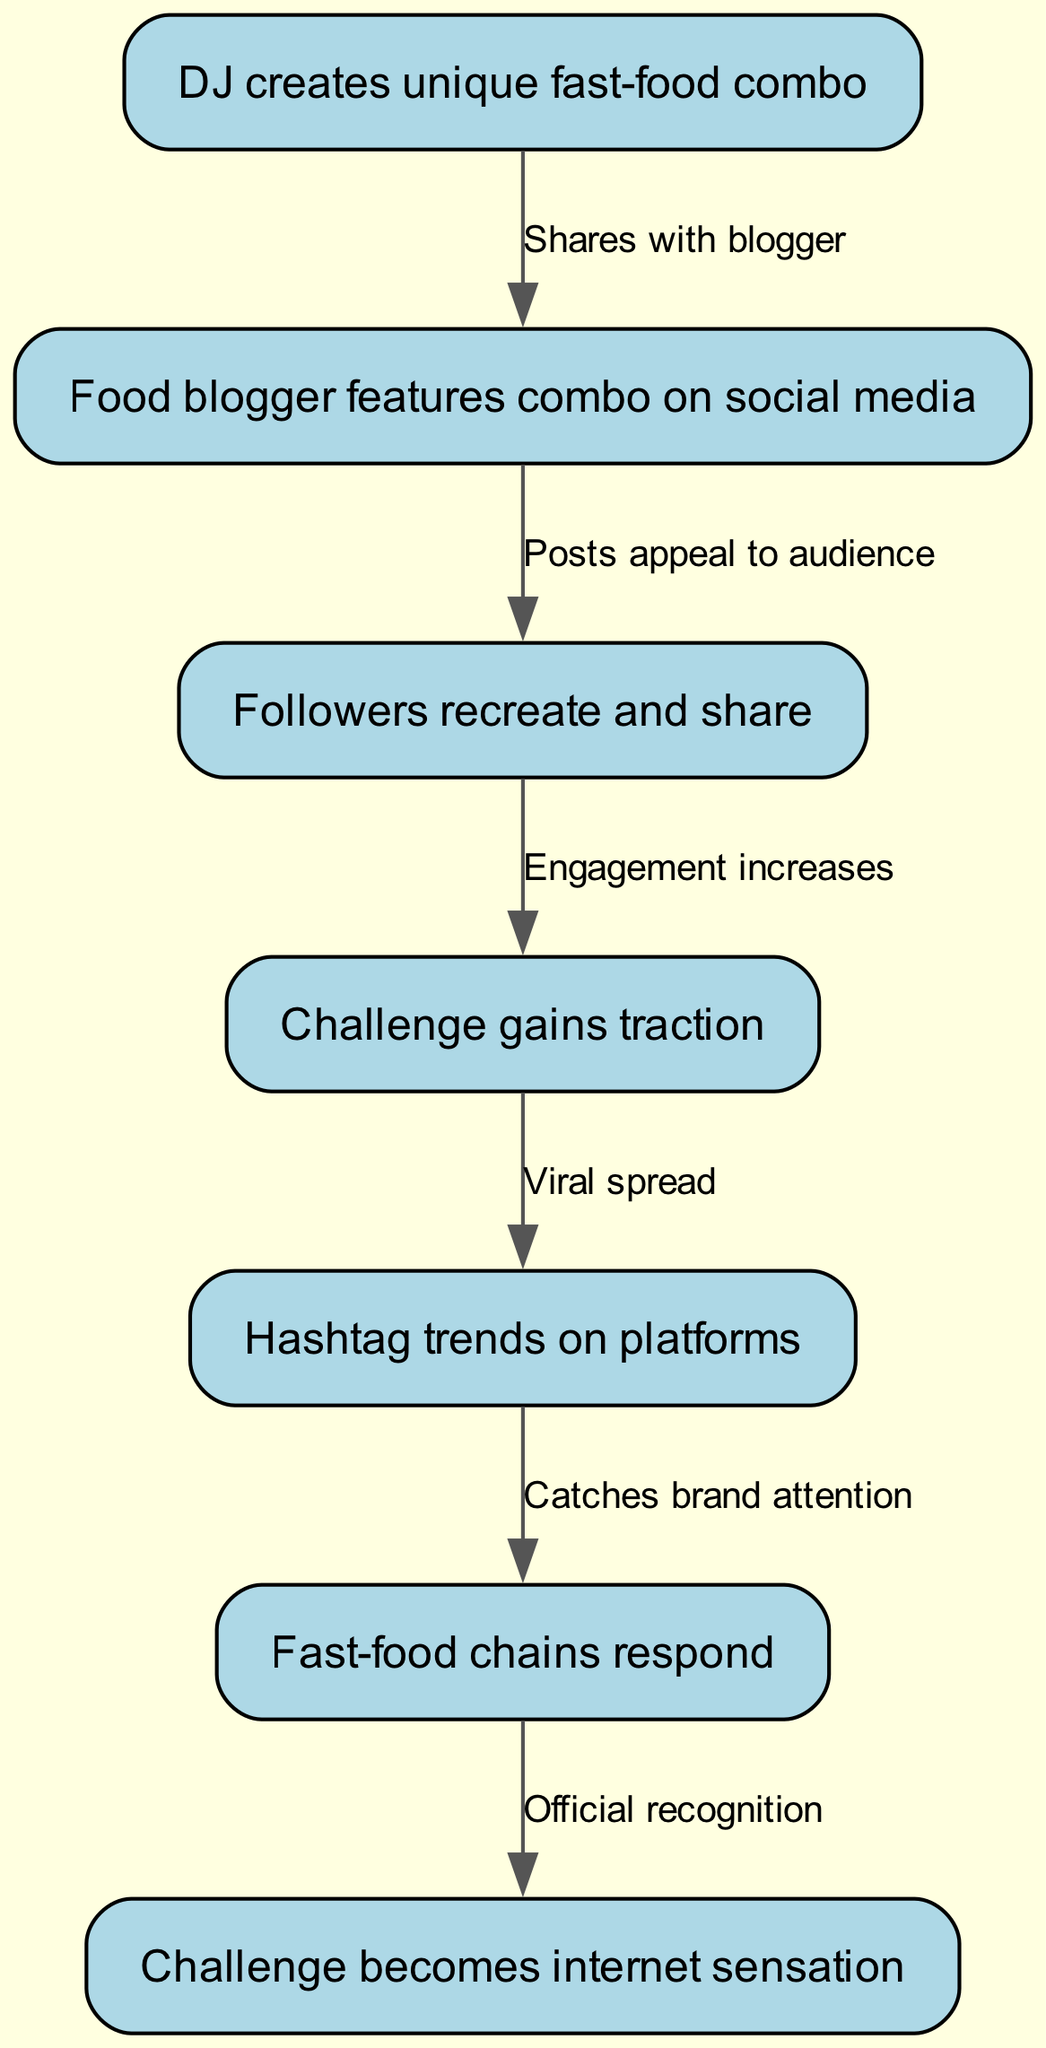What is the first step in the food challenge lifecycle? The first node in the diagram shows "DJ creates unique fast-food combo," indicating that this is where the lifecycle begins.
Answer: DJ creates unique fast-food combo How many nodes are present in the diagram? Counting all items in the nodes section, there are a total of 7 nodes listed, representing different stages of the food challenge lifecycle.
Answer: 7 What follows after the food blogger features the combo? The diagram shows a direct edge from node 2 ("Food blogger features combo on social media") to node 3 ("Followers recreate and share"), indicating that this is the next step in the lifecycle.
Answer: Followers recreate and share What triggers the challenge to gain traction? The edge from node 3 to node 4 shows that "Engagement increases" from followers recreating and sharing leads directly to the challenge gaining traction.
Answer: Engagement increases Which node indicates the response from fast-food chains? The node that directly follows "Hashtag trends on platforms" is "Fast-food chains respond," indicated by the edge between node 5 and node 6.
Answer: Fast-food chains respond After which event does the challenge become an internet sensation? Following the edge from node 6 ("Fast-food chains respond") to node 7 ("Challenge becomes internet sensation"), it is clear that official recognition leads to this outcome.
Answer: Official recognition What relationship exists between the trend of hashtags and brand attention? The edge connecting node 5 ("Hashtag trends on platforms") to node 6 ("Fast-food chains respond") establishes a causal relationship, indicating that the trending hashtag catches brand attention.
Answer: Catches brand attention Which stage of the diagram emphasizes user engagement? Node 3 ("Followers recreate and share") is pivotal as it highlights the active participation of followers, making user engagement a central theme at this stage.
Answer: Followers recreate and share Is there a direct connection between DJ's creation and the internet sensation? Yes, the diagram illustrates a sequential flow starting from DJ's creation (node 1) through multiple stages leading to the internet sensation (node 7), confirming a direct connection through the established process.
Answer: Yes 